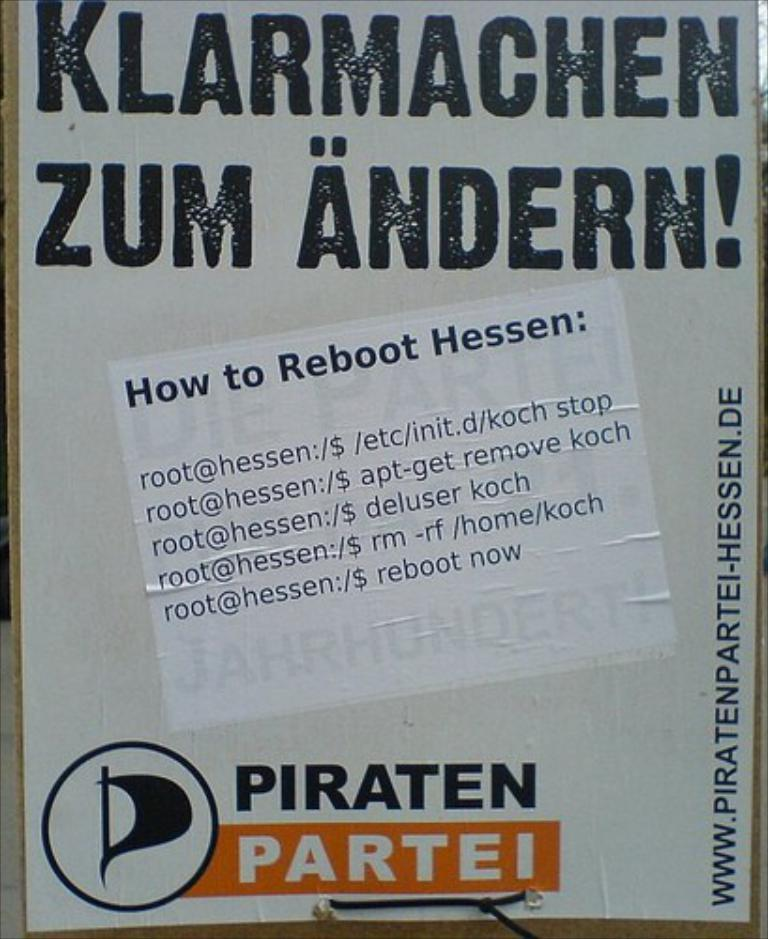Provide a one-sentence caption for the provided image. Sign that has the words "Klarmachen Zum Andern!" in large black letters. 